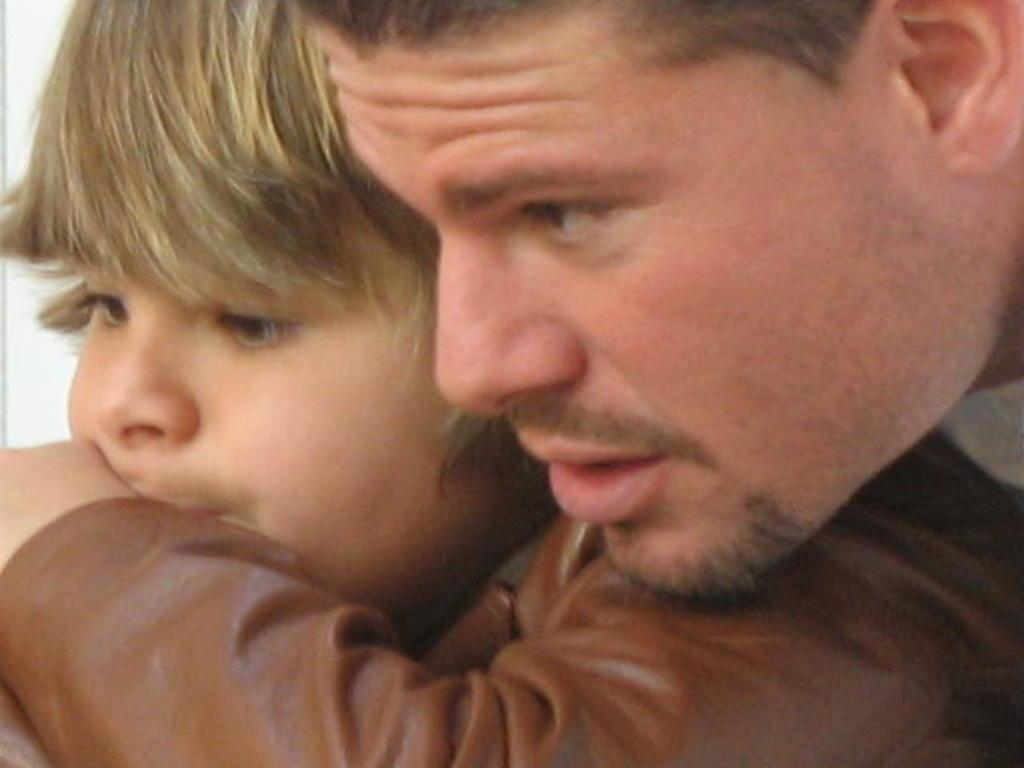Who is present in the image? There is a man and a kid in the image. Can you describe the relationship between the man and the kid? The facts provided do not give information about the relationship between the man and the kid. What are the man and the kid doing in the image? The facts provided do not give information about what the man and the kid are doing in the image. What color is the ink on the robin's beak in the image? There is no robin or ink present in the image; it only features a man and a kid. How many crows are visible in the image? There are no crows present in the image; it only features a man and a kid. 